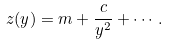Convert formula to latex. <formula><loc_0><loc_0><loc_500><loc_500>z ( y ) = m + \frac { c } { y ^ { 2 } } + \cdots \, .</formula> 